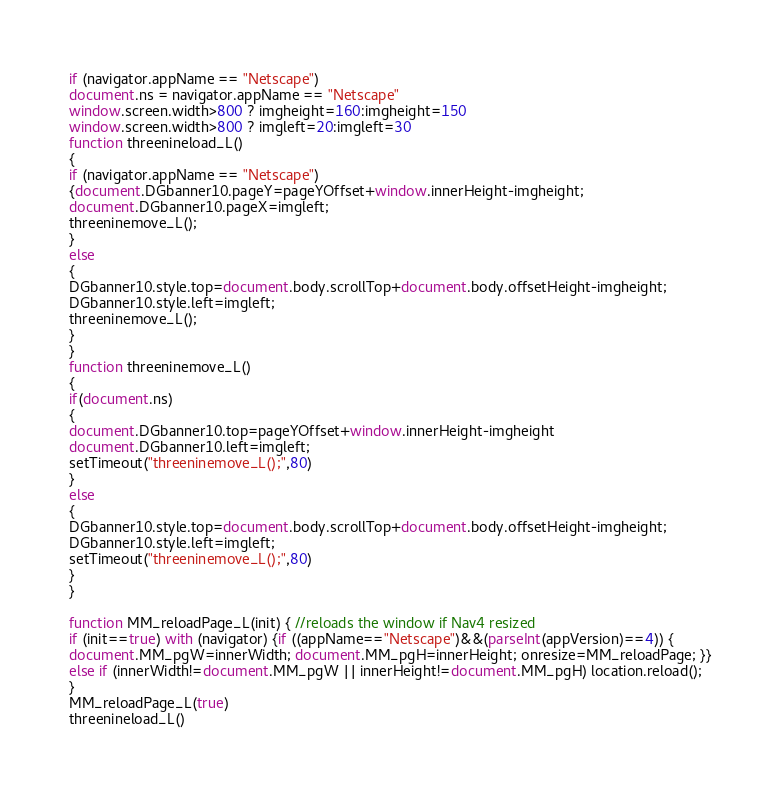Convert code to text. <code><loc_0><loc_0><loc_500><loc_500><_JavaScript_>if (navigator.appName == "Netscape")
document.ns = navigator.appName == "Netscape"
window.screen.width>800 ? imgheight=160:imgheight=150
window.screen.width>800 ? imgleft=20:imgleft=30
function threenineload_L()
{
if (navigator.appName == "Netscape")
{document.DGbanner10.pageY=pageYOffset+window.innerHeight-imgheight;
document.DGbanner10.pageX=imgleft;
threeninemove_L();
}
else
{
DGbanner10.style.top=document.body.scrollTop+document.body.offsetHeight-imgheight;
DGbanner10.style.left=imgleft;
threeninemove_L();
}
}
function threeninemove_L()
{
if(document.ns)
{
document.DGbanner10.top=pageYOffset+window.innerHeight-imgheight
document.DGbanner10.left=imgleft;
setTimeout("threeninemove_L();",80)
}
else
{
DGbanner10.style.top=document.body.scrollTop+document.body.offsetHeight-imgheight;
DGbanner10.style.left=imgleft;
setTimeout("threeninemove_L();",80)
}
}

function MM_reloadPage_L(init) { //reloads the window if Nav4 resized
if (init==true) with (navigator) {if ((appName=="Netscape")&&(parseInt(appVersion)==4)) {
document.MM_pgW=innerWidth; document.MM_pgH=innerHeight; onresize=MM_reloadPage; }}
else if (innerWidth!=document.MM_pgW || innerHeight!=document.MM_pgH) location.reload();
}
MM_reloadPage_L(true)
threenineload_L()</code> 